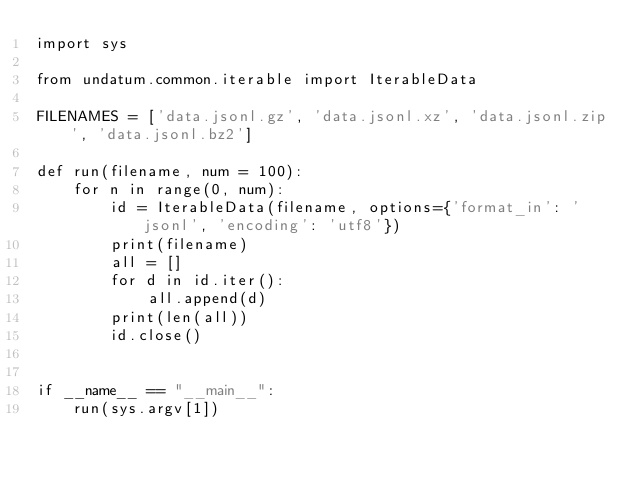<code> <loc_0><loc_0><loc_500><loc_500><_Python_>import sys

from undatum.common.iterable import IterableData

FILENAMES = ['data.jsonl.gz', 'data.jsonl.xz', 'data.jsonl.zip', 'data.jsonl.bz2']

def run(filename, num = 100):
    for n in range(0, num):
        id = IterableData(filename, options={'format_in': 'jsonl', 'encoding': 'utf8'})
        print(filename)
        all = []
        for d in id.iter():
            all.append(d)
        print(len(all))
        id.close()


if __name__ == "__main__":
    run(sys.argv[1])
</code> 